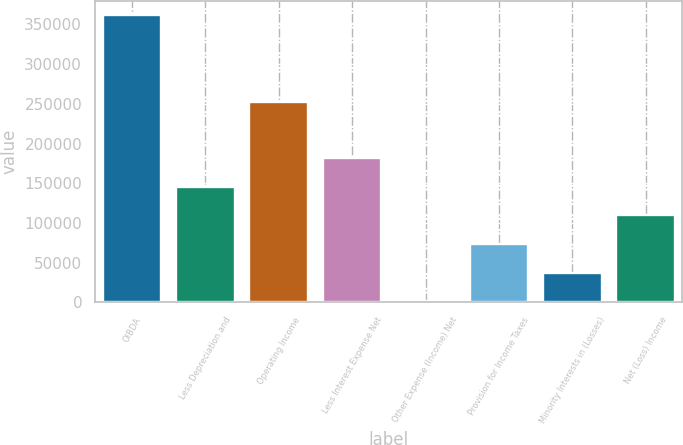Convert chart to OTSL. <chart><loc_0><loc_0><loc_500><loc_500><bar_chart><fcel>OIBDA<fcel>Less Depreciation and<fcel>Operating Income<fcel>Less Interest Expense Net<fcel>Other Expense (Income) Net<fcel>Provision for Income Taxes<fcel>Minority Interests in (Losses)<fcel>Net (Loss) Income<nl><fcel>361578<fcel>145492<fcel>252586<fcel>181506<fcel>1435<fcel>73463.6<fcel>37449.3<fcel>109478<nl></chart> 